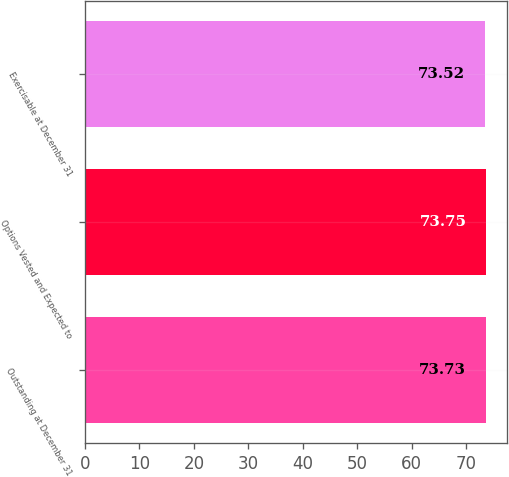Convert chart. <chart><loc_0><loc_0><loc_500><loc_500><bar_chart><fcel>Outstanding at December 31<fcel>Options Vested and Expected to<fcel>Exercisable at December 31<nl><fcel>73.73<fcel>73.75<fcel>73.52<nl></chart> 